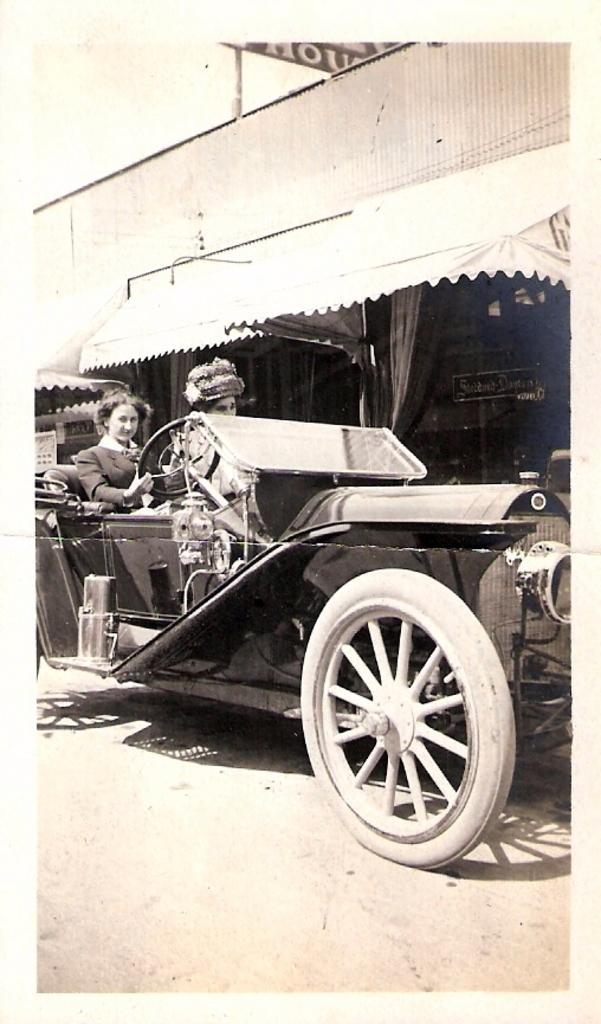Can you describe this image briefly? In this picture there is a old vintage car. There is a woman driving this car. Beside her there is another person sitting in the car. In the background there is a building. The car is on the road. 